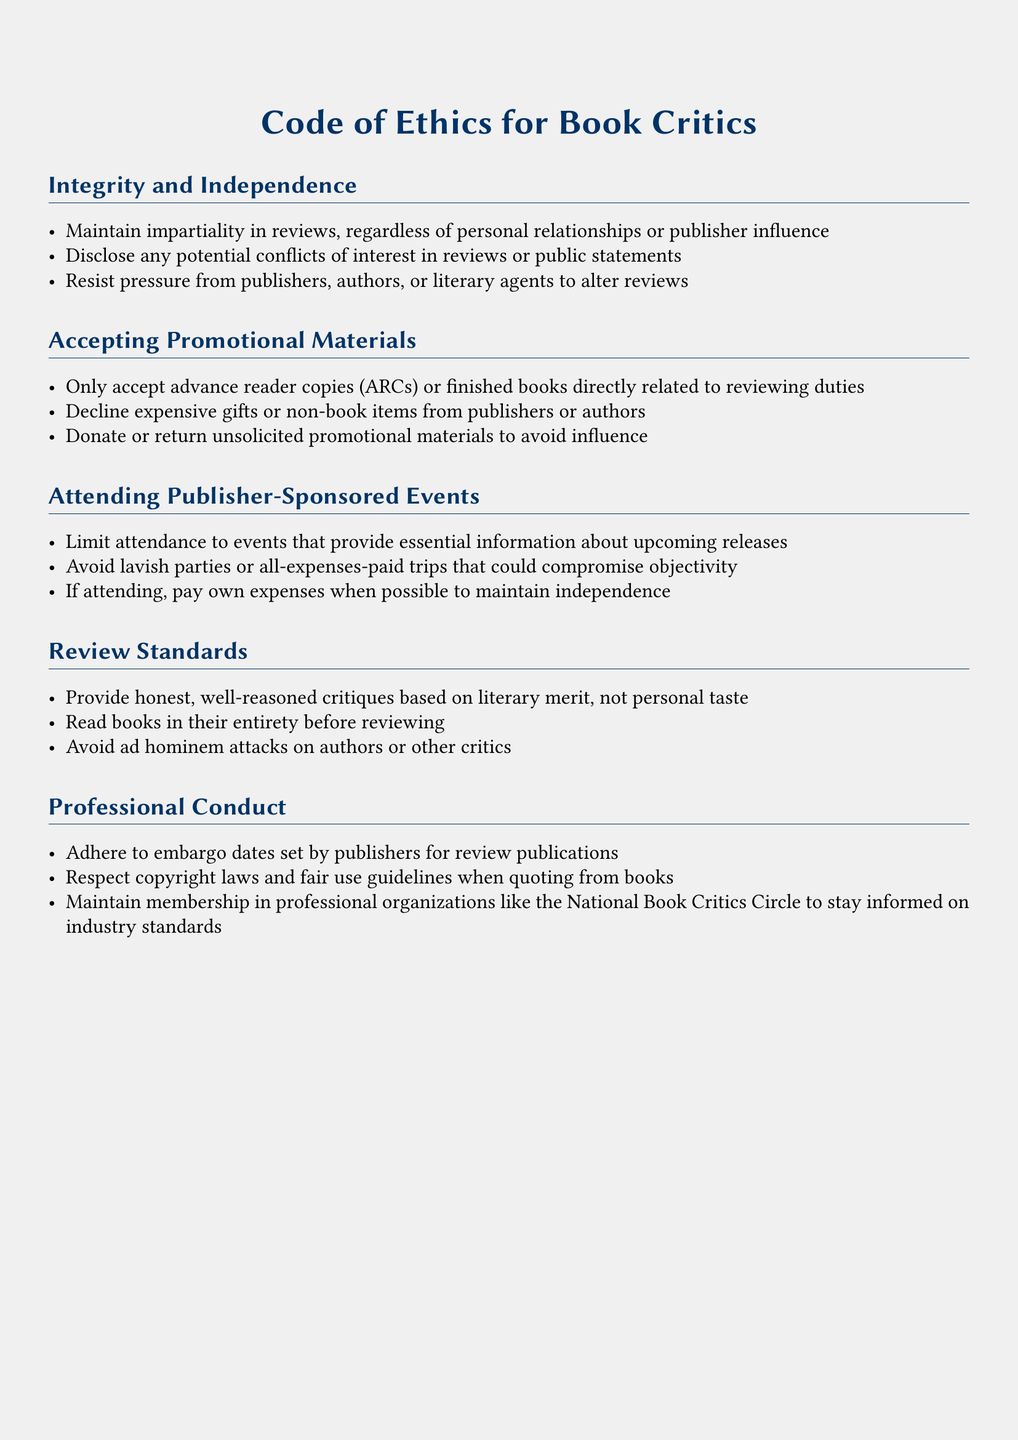What is the title of the document? The title of the document is stated at the beginning, describing the purpose of the guidelines.
Answer: Code of Ethics for Book Critics What should critics do with unsolicited promotional materials? This is mentioned under the section about accepting promotional materials.
Answer: Donate or return What type of events should critics limit attendance to? This question pertains to the guidelines for attending publisher-sponsored events.
Answer: Essential information What is required before writing a review? This requirement is stated in the review standards section.
Answer: Read books in their entirety What is one of the key principles critics must maintain? This is stated in the integrity and independence section of the document.
Answer: Impartiality How should critics address personal relationships with publishers? This relates to maintaining integrity in their reviews.
Answer: Disclose conflicts of interest What should critics avoid when reviewing literary works? This is outlined in the review standards.
Answer: Ad hominem attacks What is the purpose of maintaining membership in professional organizations? The document indicates a specific benefit of membership in professional organizations.
Answer: Stay informed 